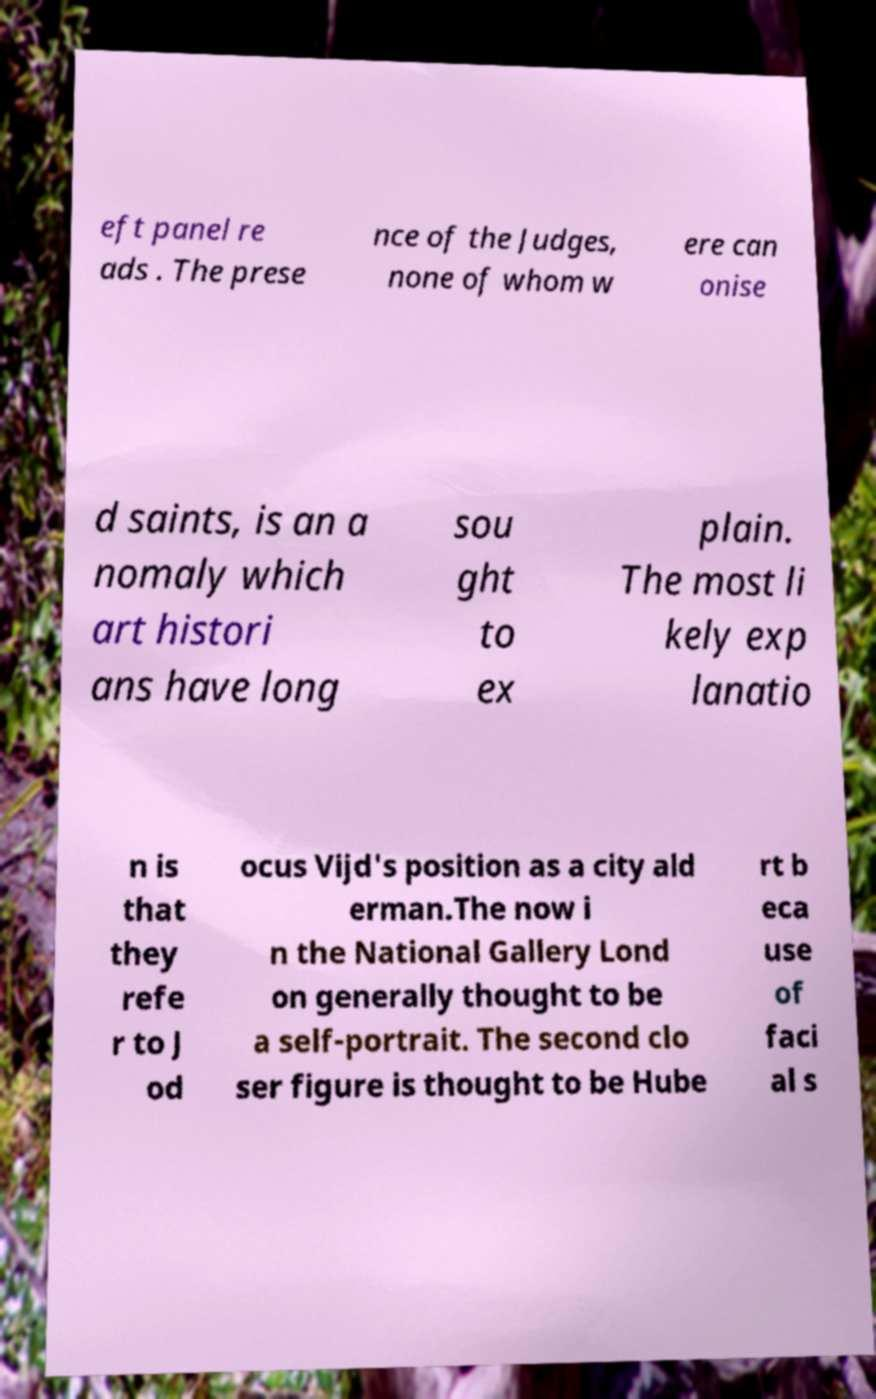Could you extract and type out the text from this image? eft panel re ads . The prese nce of the Judges, none of whom w ere can onise d saints, is an a nomaly which art histori ans have long sou ght to ex plain. The most li kely exp lanatio n is that they refe r to J od ocus Vijd's position as a city ald erman.The now i n the National Gallery Lond on generally thought to be a self-portrait. The second clo ser figure is thought to be Hube rt b eca use of faci al s 